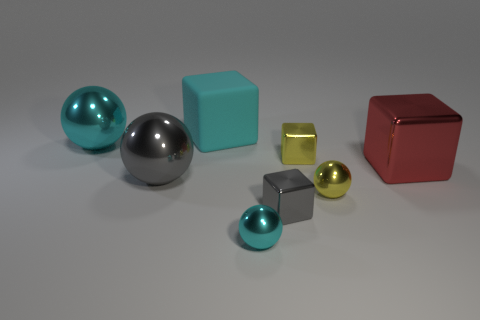There is a large matte block; does it have the same color as the big shiny thing that is behind the red metal cube?
Offer a terse response. Yes. How many other things are the same color as the large matte block?
Ensure brevity in your answer.  2. What number of cyan rubber objects are the same size as the red metal block?
Offer a very short reply. 1. Are there fewer rubber cubes that are in front of the big gray ball than yellow metal blocks in front of the large red thing?
Ensure brevity in your answer.  No. There is a cyan object that is to the left of the cyan object that is behind the cyan ball to the left of the tiny cyan ball; what size is it?
Provide a short and direct response. Large. What size is the metallic object that is both on the left side of the small cyan shiny thing and in front of the big cyan metallic ball?
Your answer should be very brief. Large. There is a small yellow thing on the right side of the tiny yellow object that is left of the yellow metallic sphere; what shape is it?
Give a very brief answer. Sphere. Is there anything else that has the same color as the large rubber object?
Your answer should be very brief. Yes. There is a gray metallic thing to the left of the large rubber cube; what is its shape?
Provide a short and direct response. Sphere. What is the shape of the large metal thing that is on the right side of the large cyan metal ball and left of the yellow metal sphere?
Your answer should be compact. Sphere. 